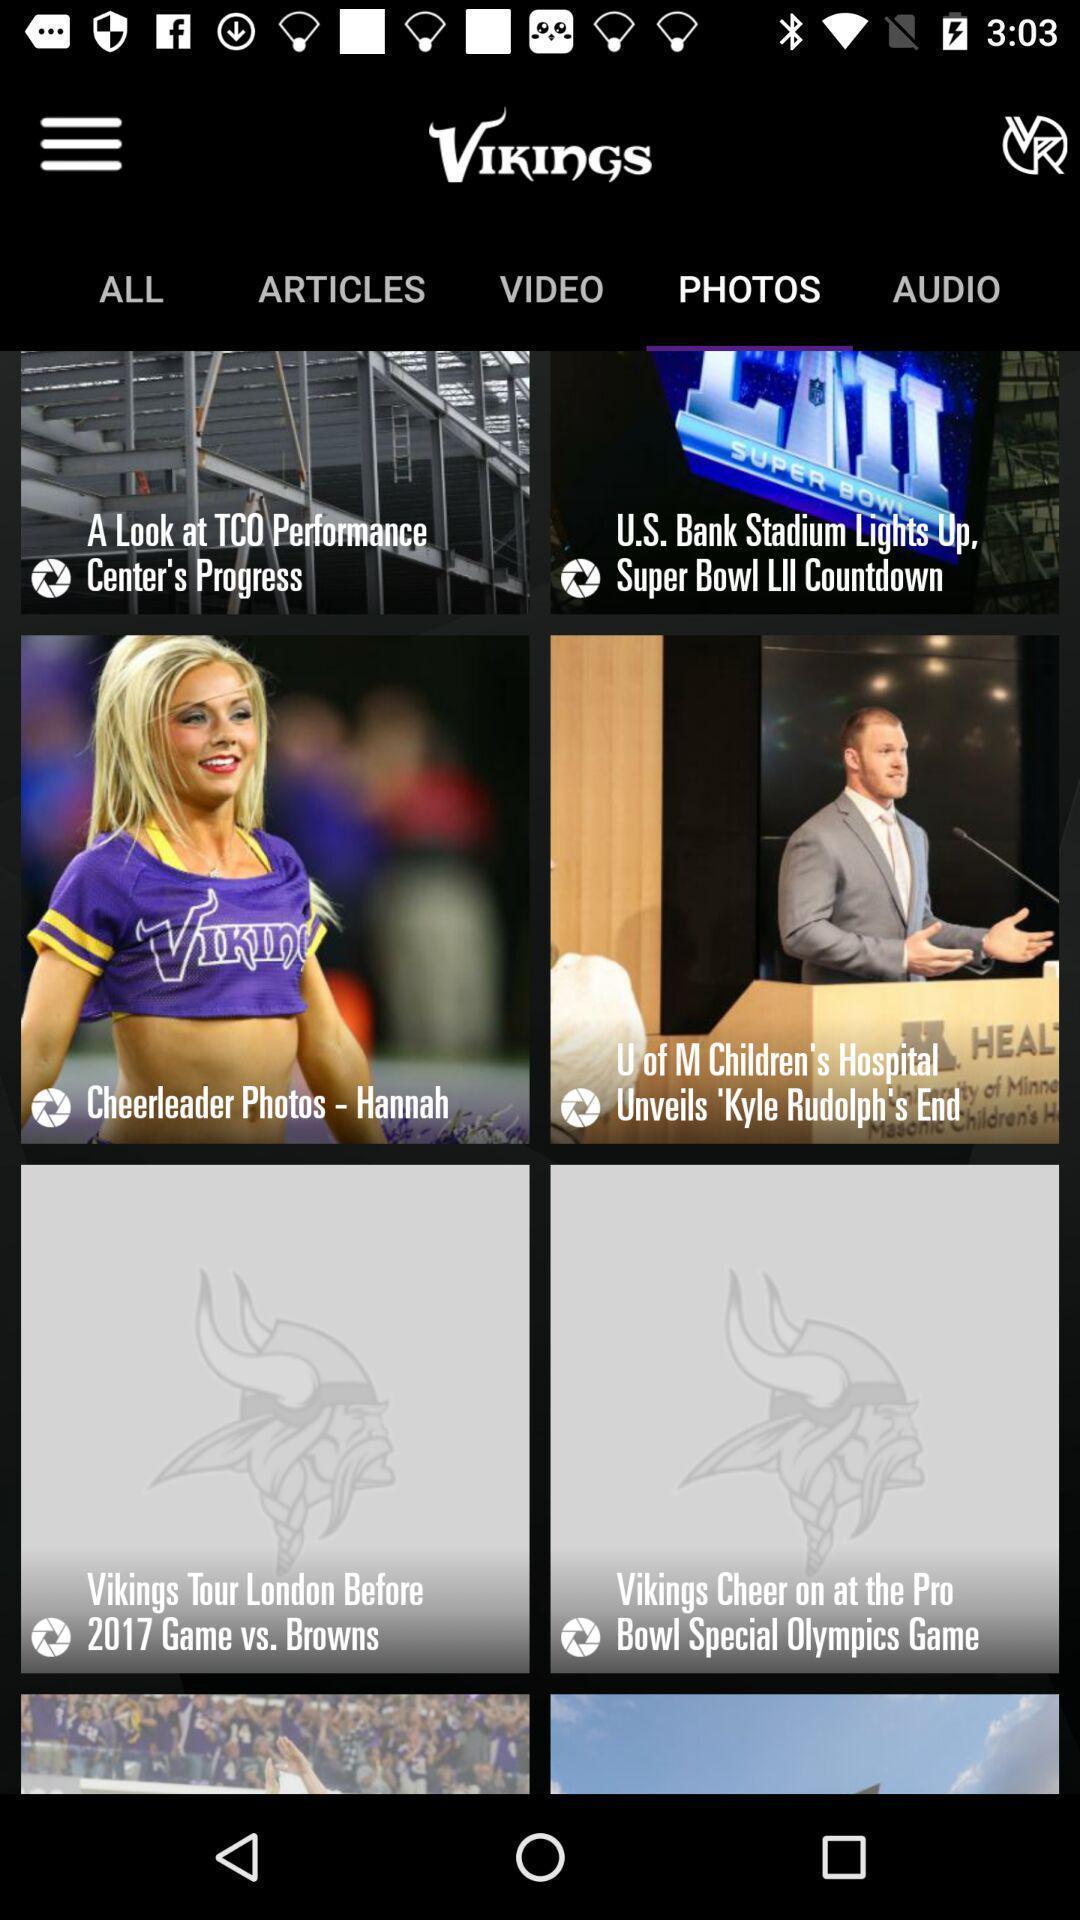Explain the elements present in this screenshot. Screen displaying photos page. 